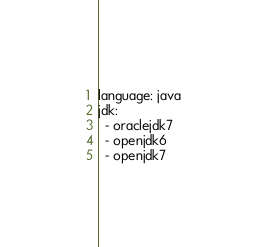<code> <loc_0><loc_0><loc_500><loc_500><_YAML_>language: java
jdk:
  - oraclejdk7
  - openjdk6
  - openjdk7</code> 